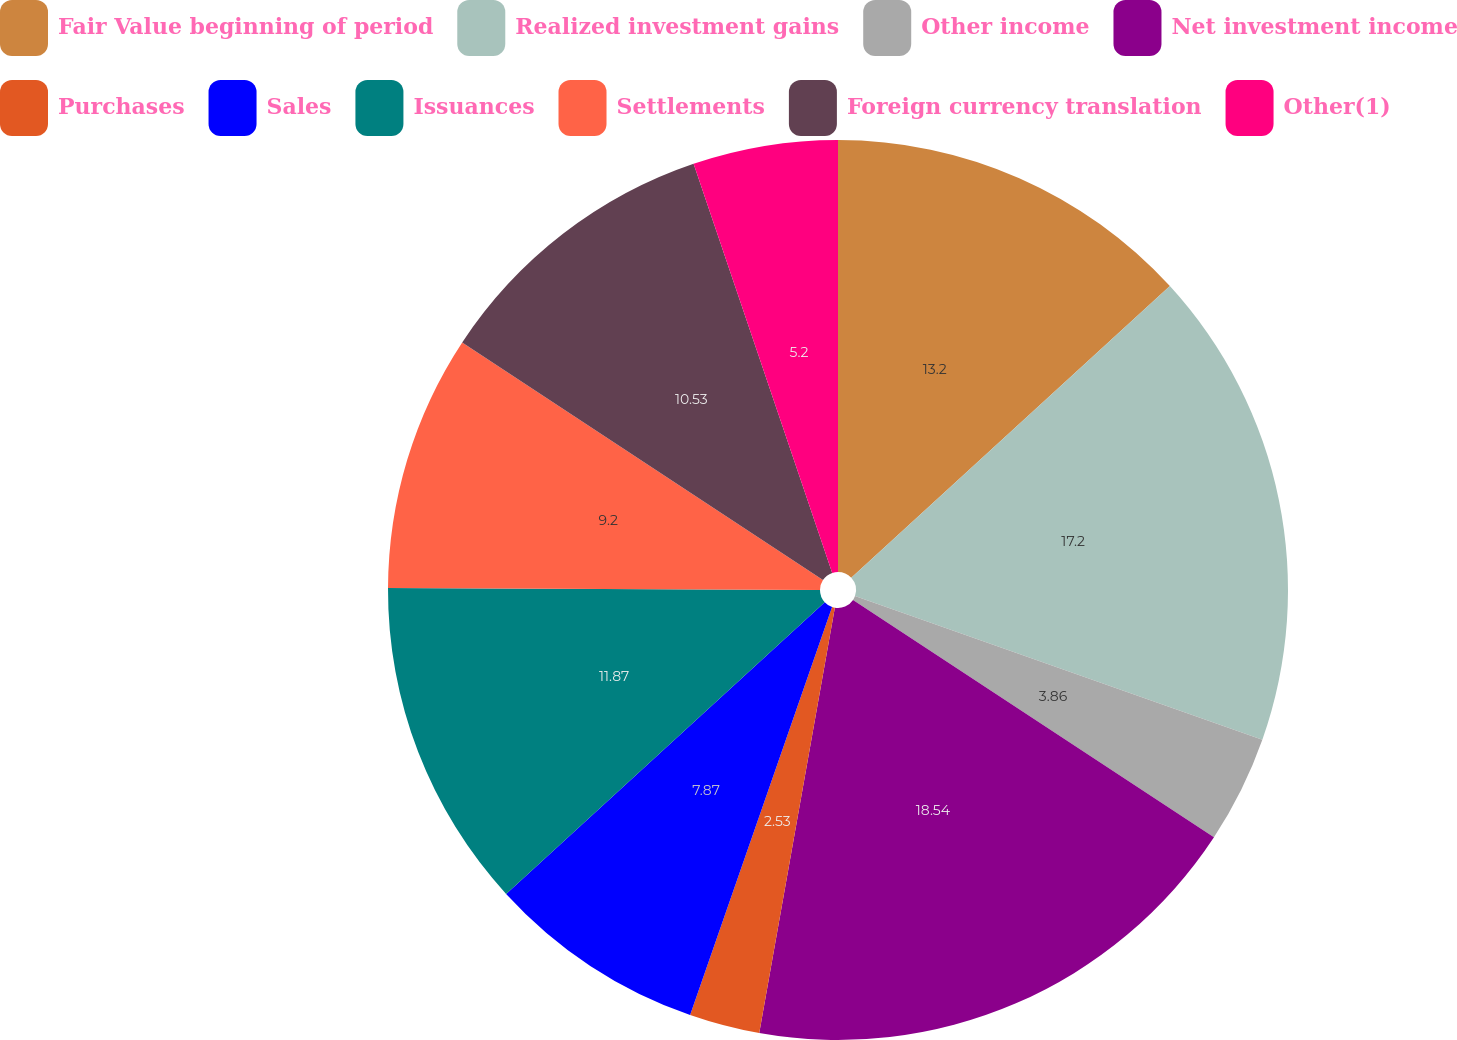<chart> <loc_0><loc_0><loc_500><loc_500><pie_chart><fcel>Fair Value beginning of period<fcel>Realized investment gains<fcel>Other income<fcel>Net investment income<fcel>Purchases<fcel>Sales<fcel>Issuances<fcel>Settlements<fcel>Foreign currency translation<fcel>Other(1)<nl><fcel>13.2%<fcel>17.2%<fcel>3.86%<fcel>18.54%<fcel>2.53%<fcel>7.87%<fcel>11.87%<fcel>9.2%<fcel>10.53%<fcel>5.2%<nl></chart> 